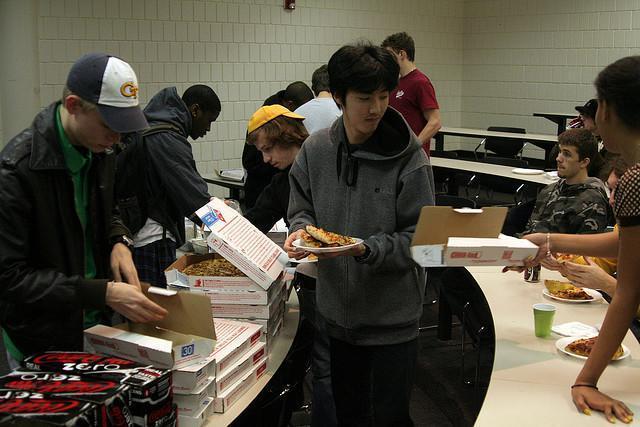How many people are there?
Give a very brief answer. 8. How many horses are there?
Give a very brief answer. 0. 